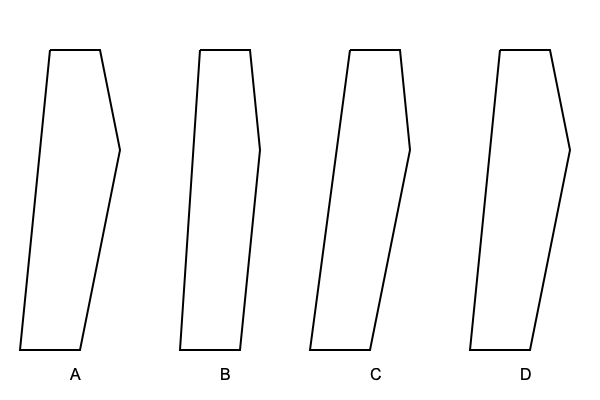As a novelist researching 1950s fashion, you come across these silhouette diagrams of men's suit styles from that era. Which silhouette represents the iconic "zoot suit" popular in the early 1950s among certain subcultures? To identify the zoot suit from the given silhouettes, let's analyze each style:

1. Silhouette A: This shows a wide shoulder line that tapers dramatically to a narrow waist and then flares out slightly at the bottom. This exaggerated shape is characteristic of the zoot suit.

2. Silhouette B: This represents a more conservative, slim-fit suit common in the 1950s. It has a natural shoulder line and a tapered waist, but lacks the extreme proportions of the zoot suit.

3. Silhouette C: This silhouette shows a moderately wide shoulder with a gentle taper to the waist and a straight leg. This likely represents a standard 1950s business suit.

4. Silhouette D: This diagram depicts a suit with padded shoulders and a full cut through the chest and waist, possibly representing an early 1950s "bold look" suit.

The zoot suit, popular in the early 1950s particularly among African American and Latino communities, was characterized by:
- Exaggerated shoulder pads
- High-waisted, wide-legged trousers
- A long coat with wide lapels

Silhouette A most closely matches these characteristics with its wide shoulders, narrow waist, and slight flare at the bottom, suggesting wider-legged trousers.
Answer: A 